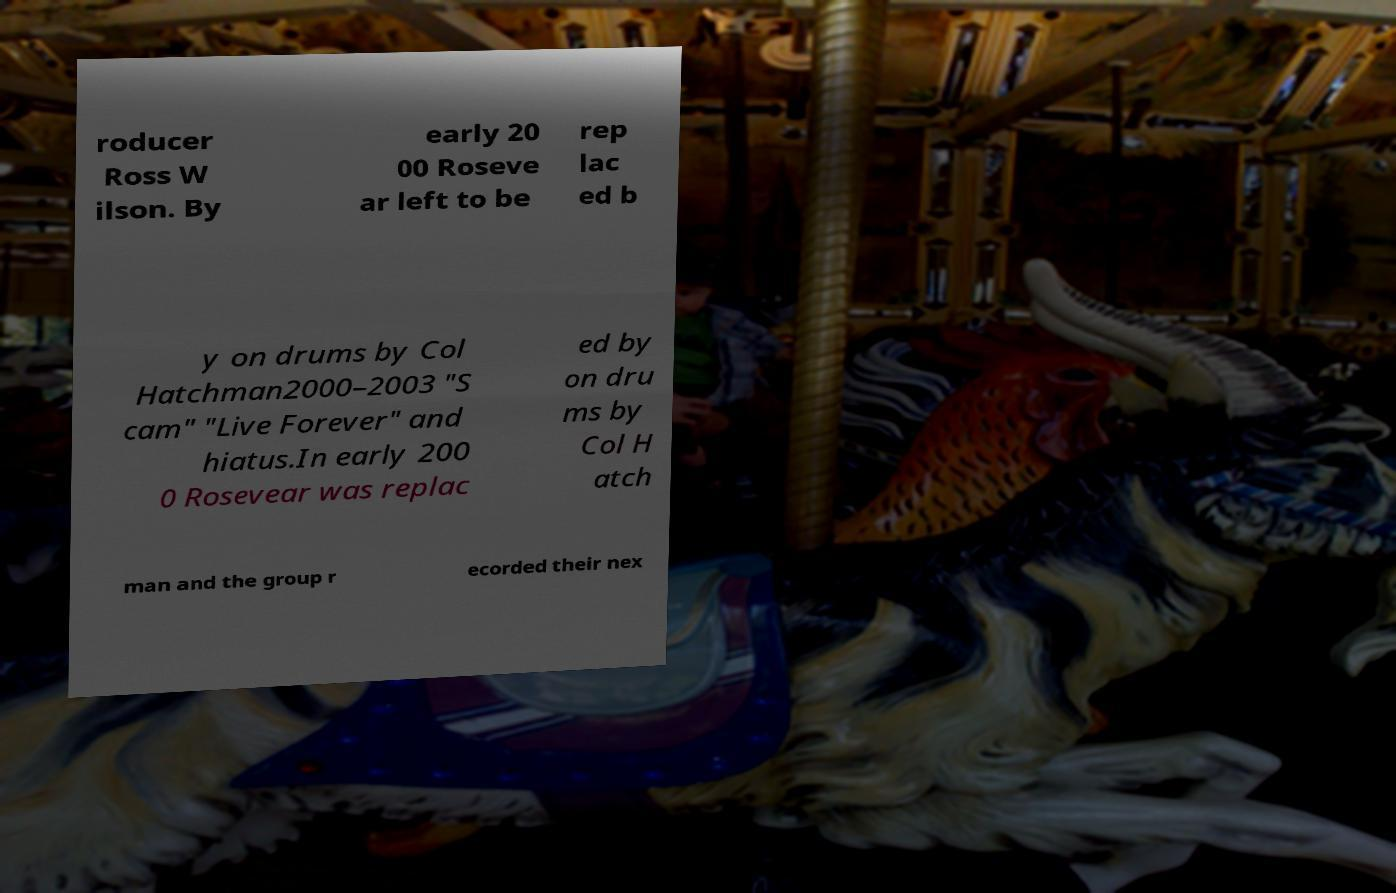Please read and relay the text visible in this image. What does it say? roducer Ross W ilson. By early 20 00 Roseve ar left to be rep lac ed b y on drums by Col Hatchman2000–2003 "S cam" "Live Forever" and hiatus.In early 200 0 Rosevear was replac ed by on dru ms by Col H atch man and the group r ecorded their nex 